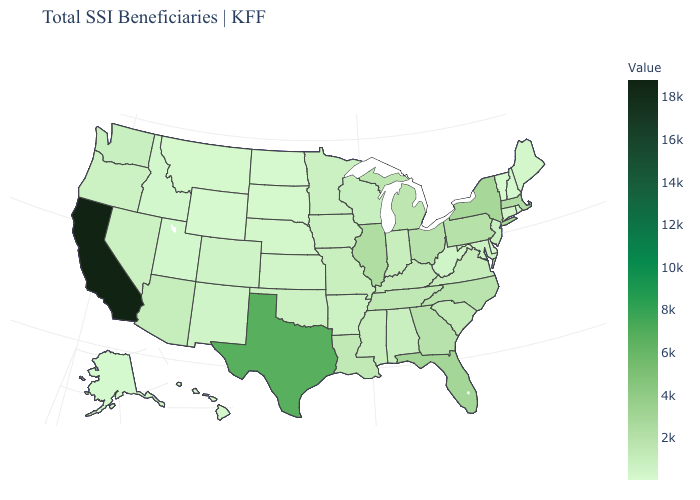Does Minnesota have the highest value in the USA?
Answer briefly. No. Among the states that border Arkansas , does Oklahoma have the lowest value?
Give a very brief answer. Yes. Does Idaho have a higher value than California?
Quick response, please. No. Which states hav the highest value in the South?
Quick response, please. Texas. Does Texas have the highest value in the USA?
Be succinct. No. 